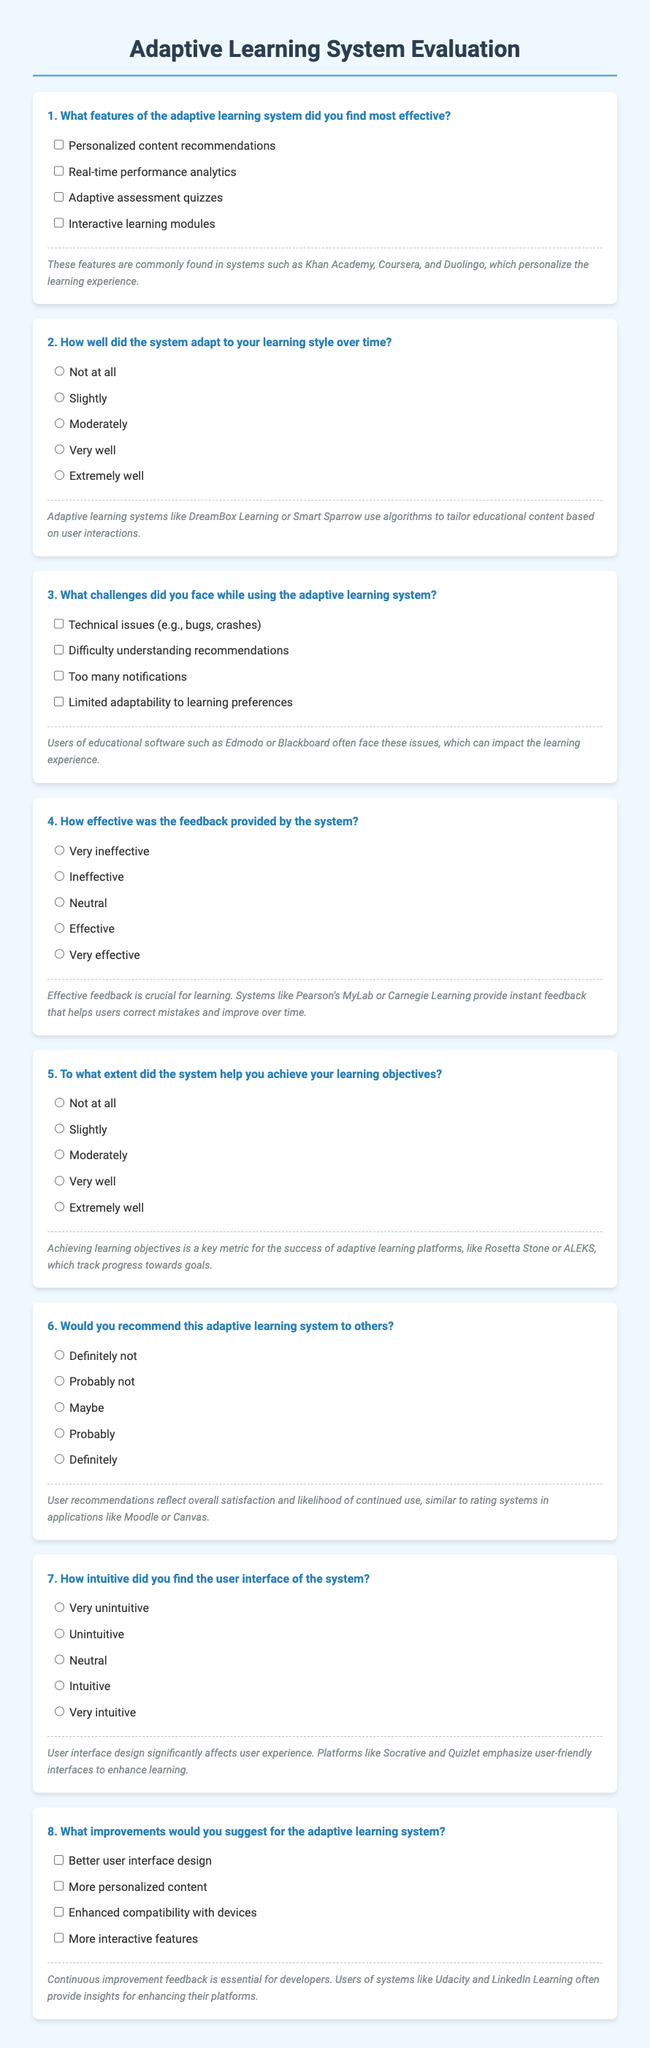What is the title of the document? The title of the document is represented in the header section, which is "Adaptive Learning System Evaluation."
Answer: Adaptive Learning System Evaluation What feature is mentioned first in the effective features list? The first feature listed in the effectiveness section is "Personalized content recommendations."
Answer: Personalized content recommendations How did the respondents rate the system's adaptability? The adaptability question offers ratings from "Not at all" to "Extremely well," with "Very well" and "Extremely well" being high ratings.
Answer: Very well What is one challenge users reported facing? One of the challenges listed is "Technical issues."
Answer: Technical issues How does the document suggest users feel about the system's user interface? The user interface question ranges from "Very unintuitive" to "Very intuitive," indicating varying degrees of ease for users.
Answer: Intuitive What is the most effective feedback type highlighted in the document? The feedback effectiveness question offers a range from "Very ineffective" to "Very effective," with "Effective" being a notable option.
Answer: Effective Which educational software platforms are mentioned as examples of effective feedback? The document cites "Pearson's MyLab" and "Carnegie Learning" as systems providing effective feedback.
Answer: Pearson's MyLab, Carnegie Learning How many options are provided for recommending the adaptive learning system? The recommendation question offers five options for response, indicating a range of preferences.
Answer: Five What suggestion for improvement relates to user experience? The improvement suggestion related to user experience is "Better user interface design."
Answer: Better user interface design 